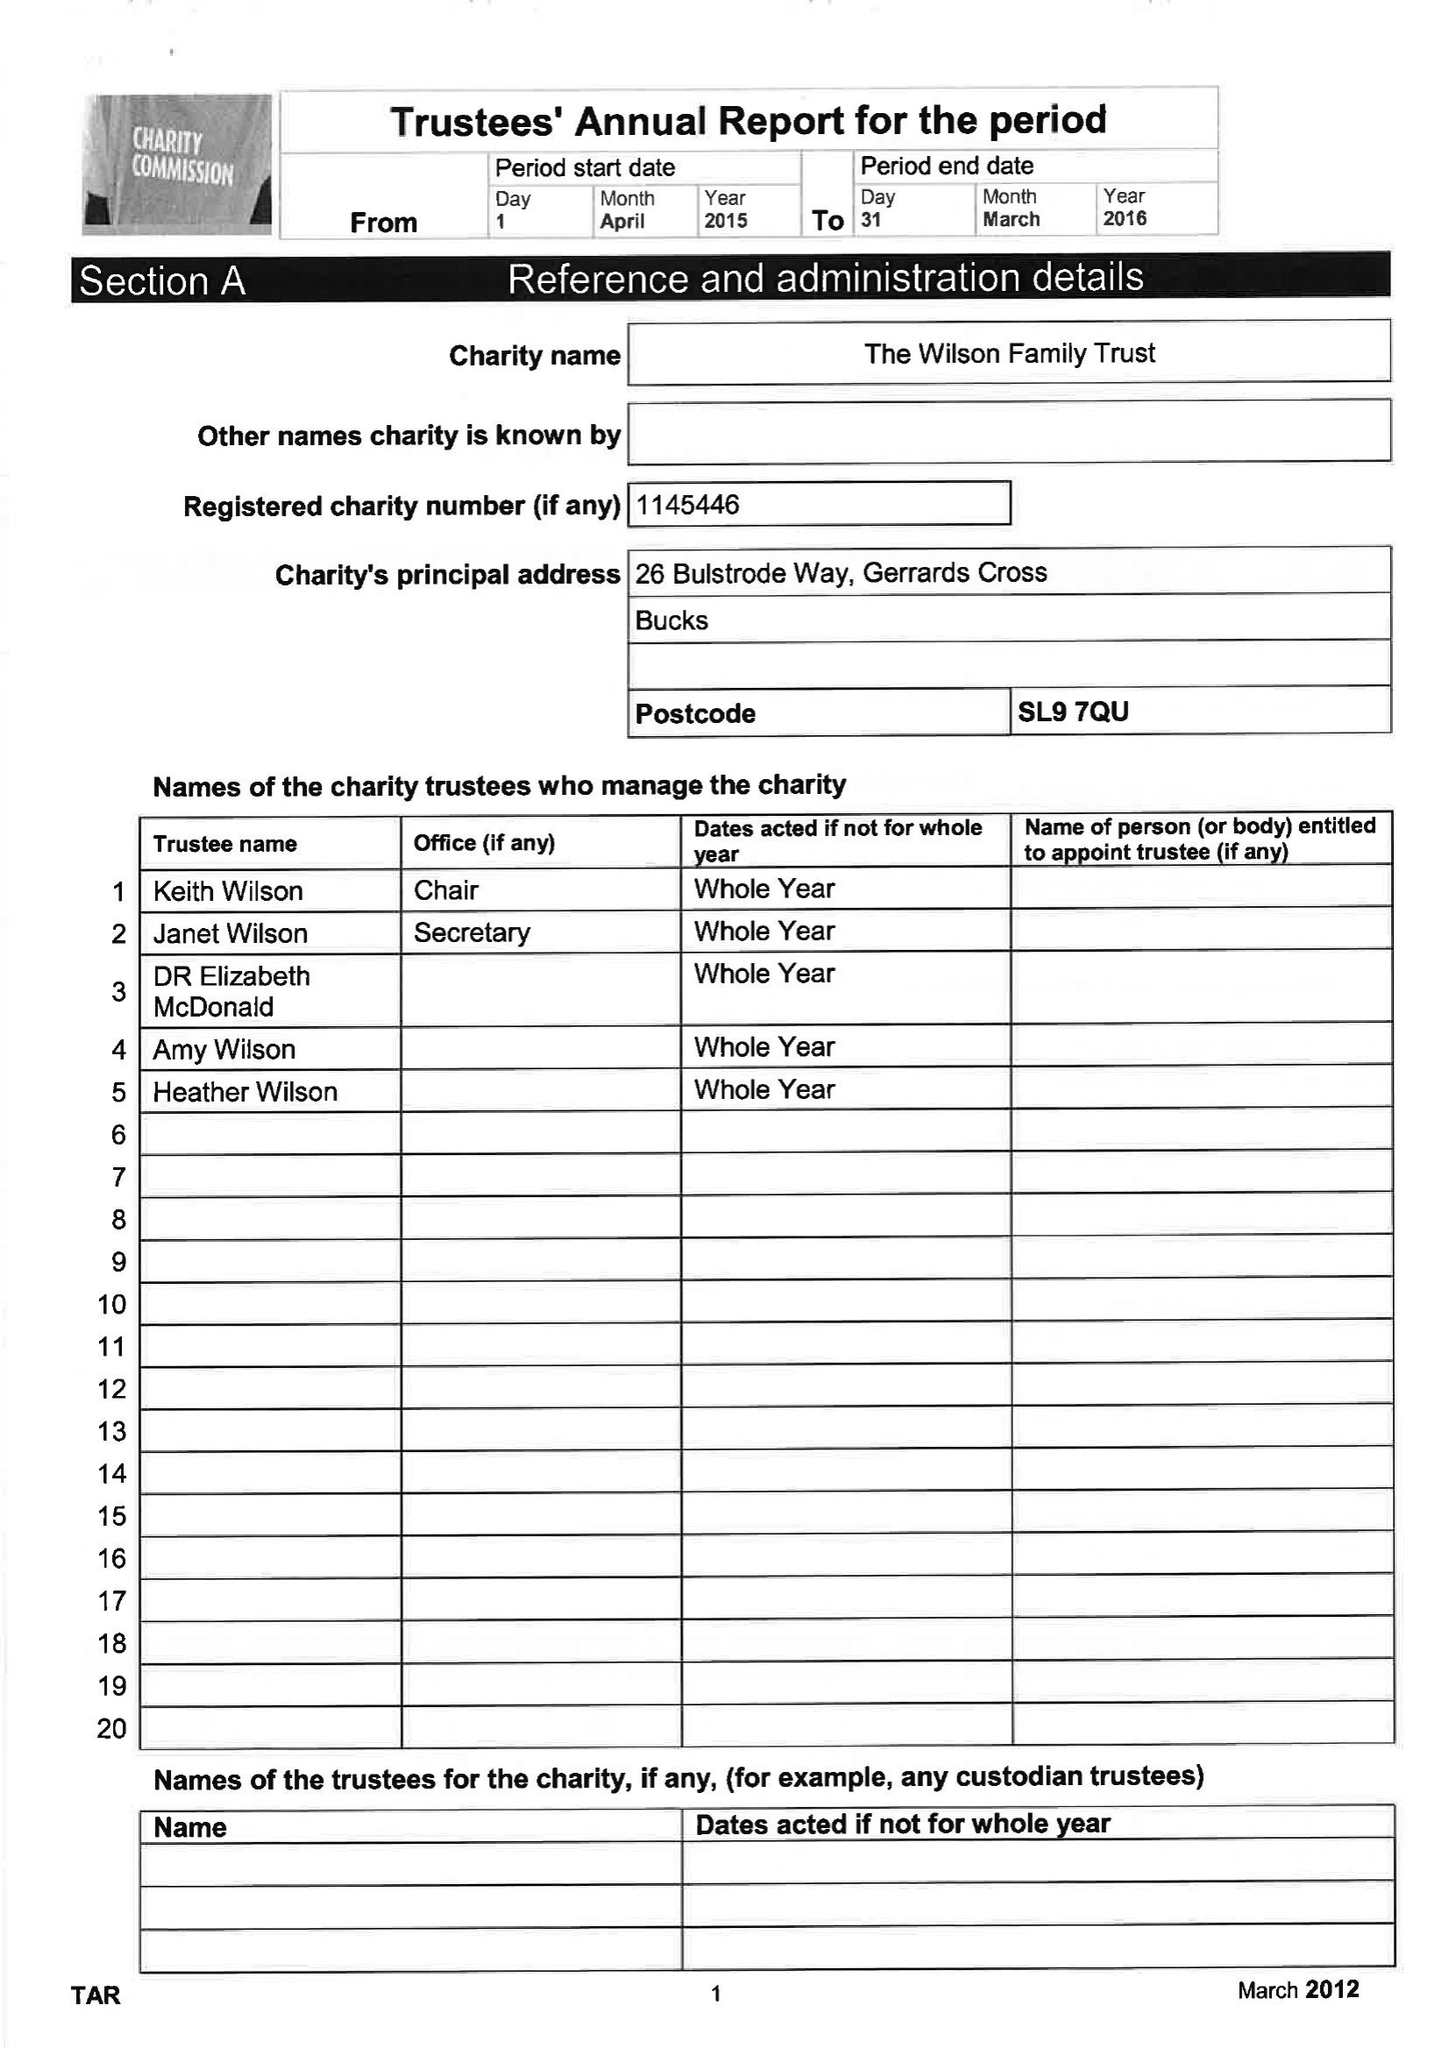What is the value for the spending_annually_in_british_pounds?
Answer the question using a single word or phrase. 197865.00 